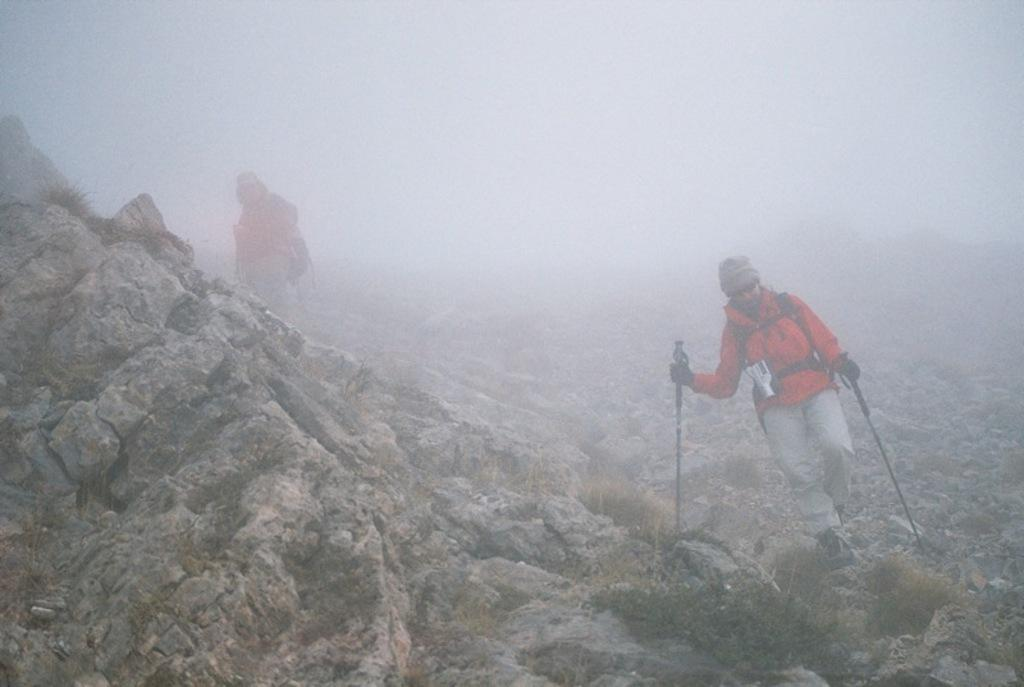How many people are in the image? There are two persons in the image. What are the two persons doing in the image? The two persons are walking. Where are the two persons walking in the image? The location of the walking is on a mountain. What type of roof can be seen in the image? There is no roof present in the image, as the two persons are walking on a mountain. How many bites can be seen being taken out of the mountain in the image? There is no indication of anyone taking bites out of the mountain in the image. 